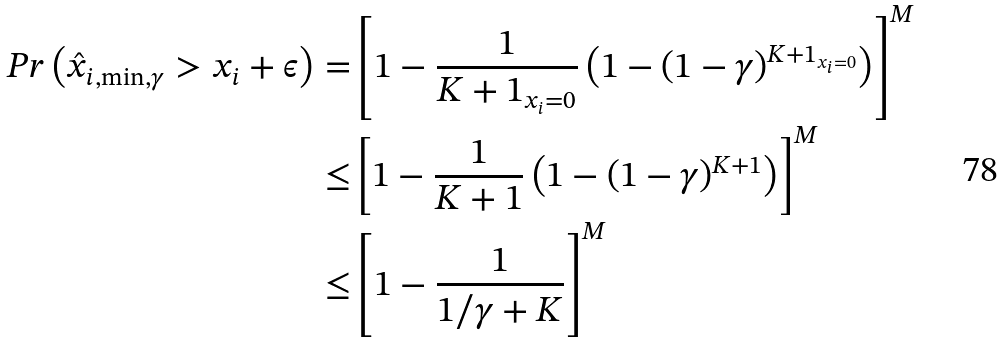<formula> <loc_0><loc_0><loc_500><loc_500>P r \left ( \hat { x } _ { i , \min , \gamma } > x _ { i } + \epsilon \right ) = & \left [ 1 - \frac { 1 } { K + 1 _ { x _ { i } = 0 } } \left ( 1 - ( 1 - \gamma ) ^ { K + 1 _ { x _ { i } = 0 } } \right ) \right ] ^ { M } \\ \leq & \left [ 1 - \frac { 1 } { K + 1 } \left ( 1 - ( 1 - \gamma ) ^ { K + 1 } \right ) \right ] ^ { M } \\ \leq & \left [ 1 - \frac { 1 } { 1 / \gamma + K } \right ] ^ { M }</formula> 